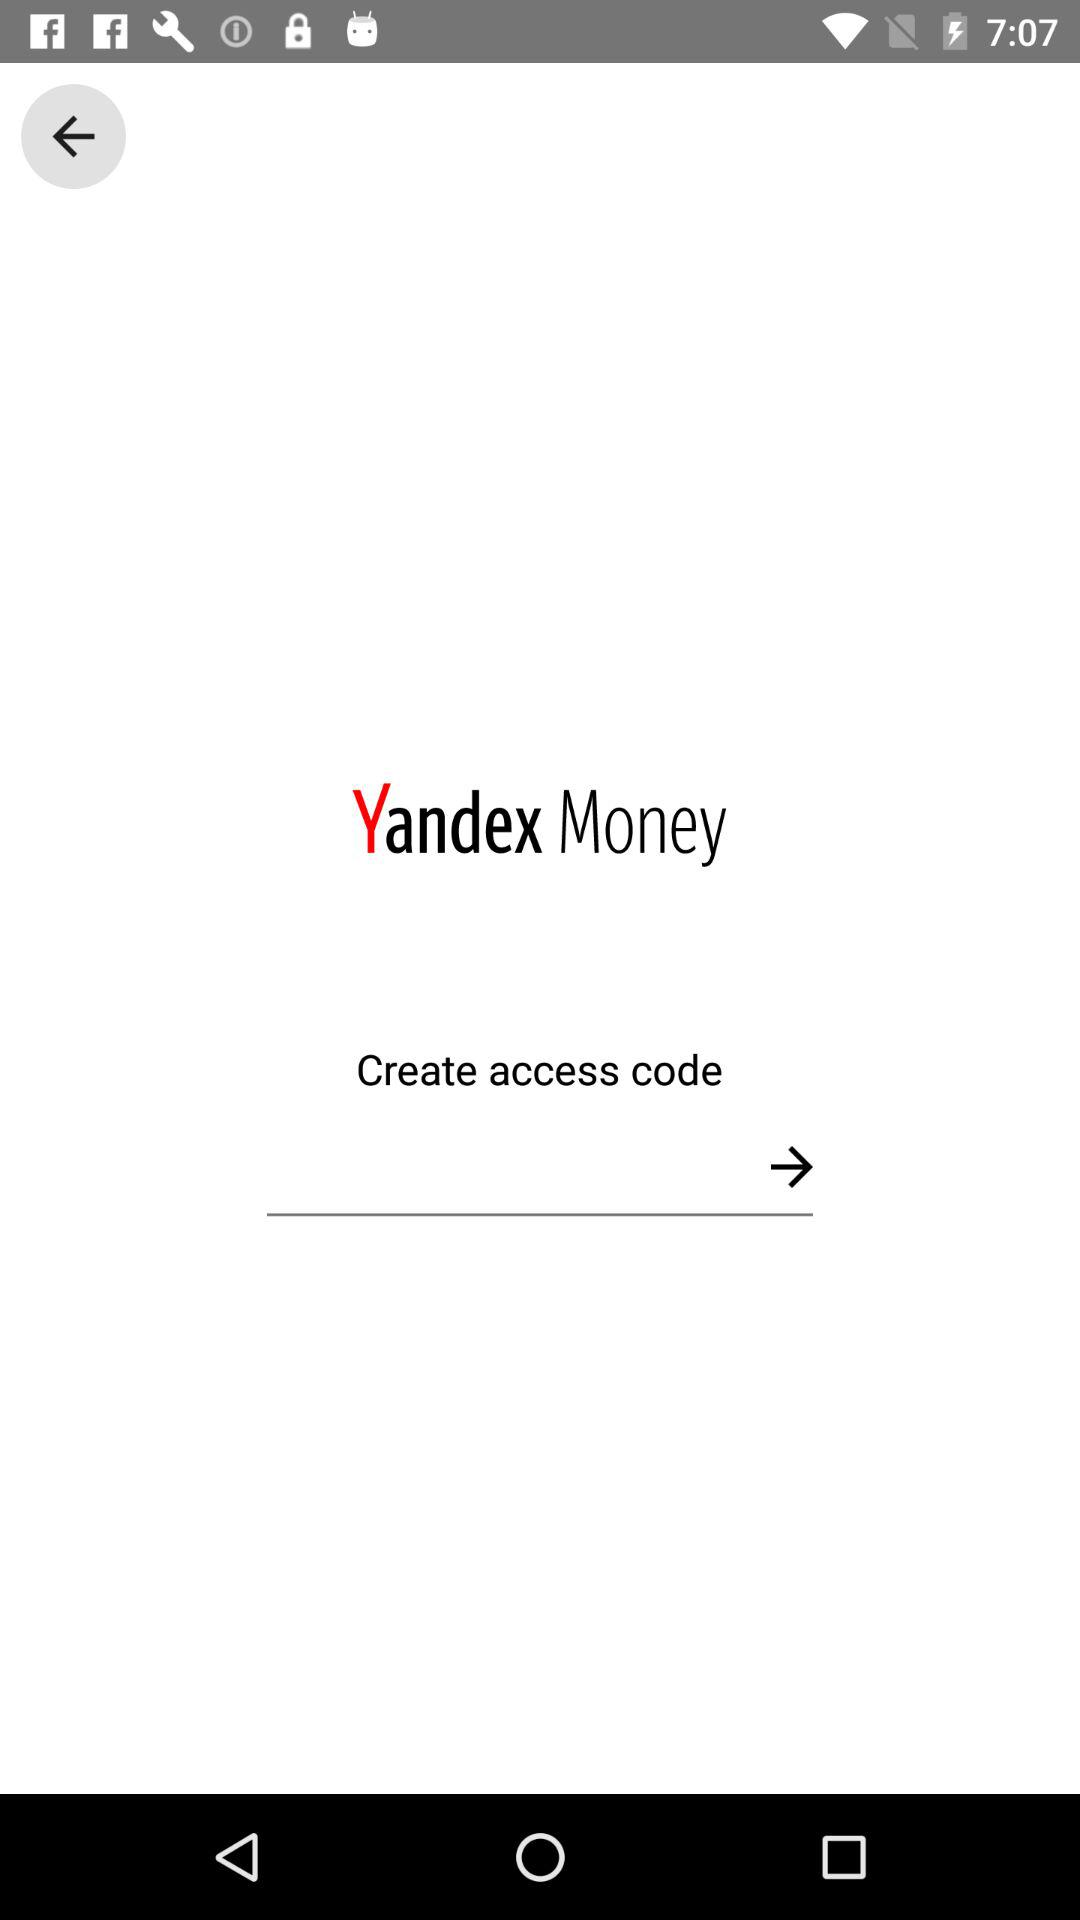What is the application name? The application name is "Yandex Money". 